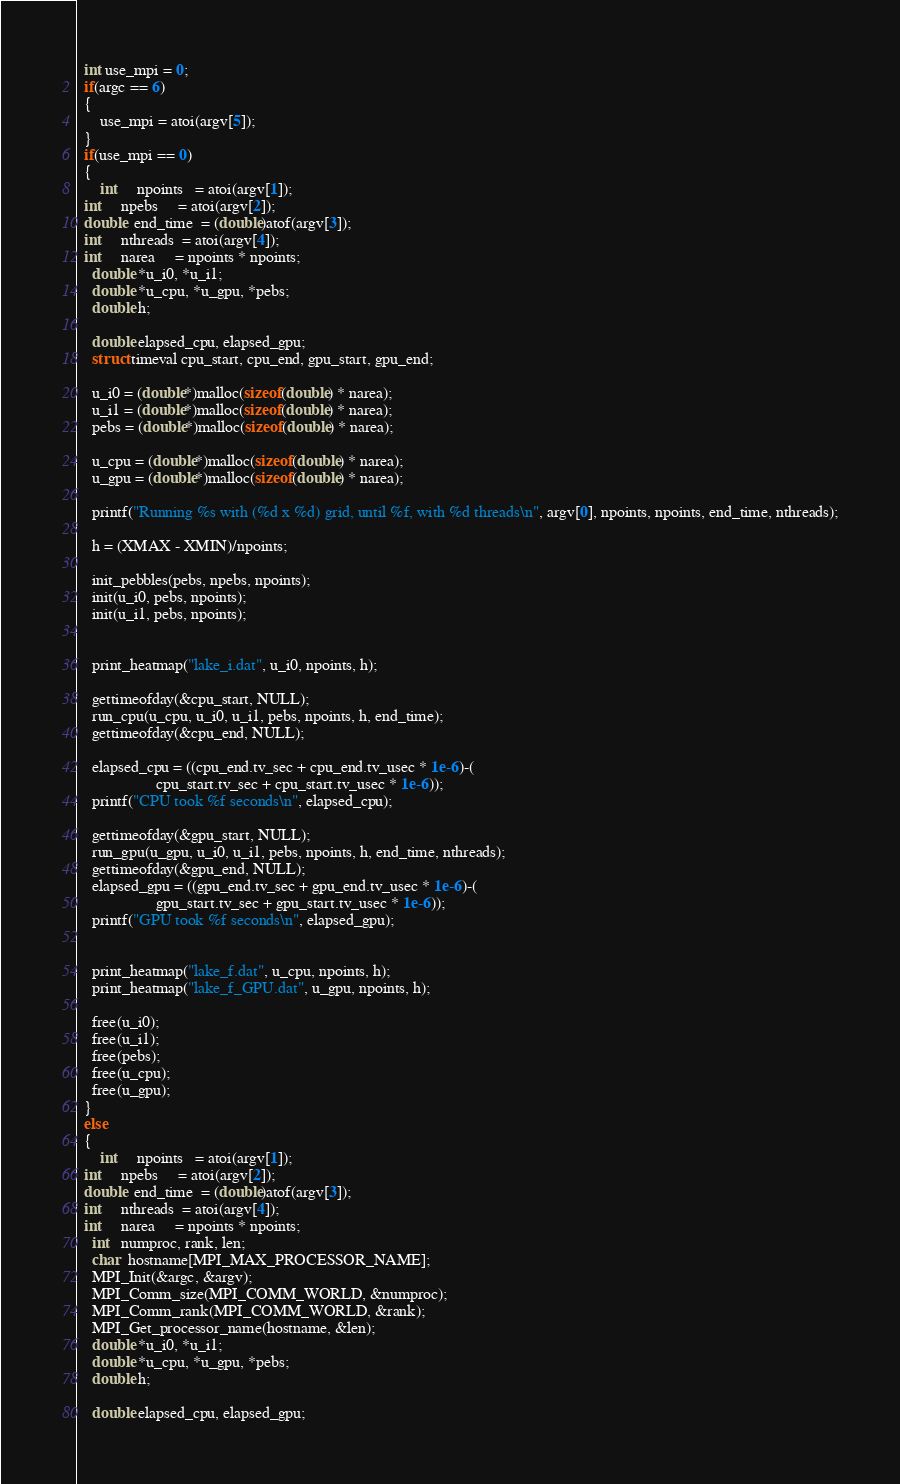Convert code to text. <code><loc_0><loc_0><loc_500><loc_500><_Cuda_>  int use_mpi = 0;
  if(argc == 6)
  {
	  use_mpi = atoi(argv[5]);
  }
  if(use_mpi == 0)
  {
      int     npoints   = atoi(argv[1]);
  int     npebs     = atoi(argv[2]);
  double  end_time  = (double)atof(argv[3]);
  int     nthreads  = atoi(argv[4]);
  int     narea     = npoints * npoints;
    double *u_i0, *u_i1;
    double *u_cpu, *u_gpu, *pebs;
    double h;

    double elapsed_cpu, elapsed_gpu;
    struct timeval cpu_start, cpu_end, gpu_start, gpu_end;
    
    u_i0 = (double*)malloc(sizeof(double) * narea);
    u_i1 = (double*)malloc(sizeof(double) * narea);
    pebs = (double*)malloc(sizeof(double) * narea);

    u_cpu = (double*)malloc(sizeof(double) * narea);
    u_gpu = (double*)malloc(sizeof(double) * narea);

    printf("Running %s with (%d x %d) grid, until %f, with %d threads\n", argv[0], npoints, npoints, end_time, nthreads);

    h = (XMAX - XMIN)/npoints;

    init_pebbles(pebs, npebs, npoints);
    init(u_i0, pebs, npoints);
    init(u_i1, pebs, npoints);

    	
    print_heatmap("lake_i.dat", u_i0, npoints, h);

    gettimeofday(&cpu_start, NULL);
    run_cpu(u_cpu, u_i0, u_i1, pebs, npoints, h, end_time);
    gettimeofday(&cpu_end, NULL);

    elapsed_cpu = ((cpu_end.tv_sec + cpu_end.tv_usec * 1e-6)-(
                    cpu_start.tv_sec + cpu_start.tv_usec * 1e-6));
    printf("CPU took %f seconds\n", elapsed_cpu);

    gettimeofday(&gpu_start, NULL);
    run_gpu(u_gpu, u_i0, u_i1, pebs, npoints, h, end_time, nthreads);
    gettimeofday(&gpu_end, NULL);
    elapsed_gpu = ((gpu_end.tv_sec + gpu_end.tv_usec * 1e-6)-(
                    gpu_start.tv_sec + gpu_start.tv_usec * 1e-6));
    printf("GPU took %f seconds\n", elapsed_gpu);


    print_heatmap("lake_f.dat", u_cpu, npoints, h);
    print_heatmap("lake_f_GPU.dat", u_gpu, npoints, h);

    free(u_i0);
    free(u_i1);
    free(pebs);
    free(u_cpu);
    free(u_gpu);
  }
  else
  {
      int     npoints   = atoi(argv[1]);
  int     npebs     = atoi(argv[2]);
  double  end_time  = (double)atof(argv[3]);
  int     nthreads  = atoi(argv[4]);
  int     narea     = npoints * npoints;
    int   numproc, rank, len;
    char  hostname[MPI_MAX_PROCESSOR_NAME];
    MPI_Init(&argc, &argv);
    MPI_Comm_size(MPI_COMM_WORLD, &numproc);
    MPI_Comm_rank(MPI_COMM_WORLD, &rank);
    MPI_Get_processor_name(hostname, &len);
    double *u_i0, *u_i1;
    double *u_cpu, *u_gpu, *pebs;
    double h;

    double elapsed_cpu, elapsed_gpu;</code> 